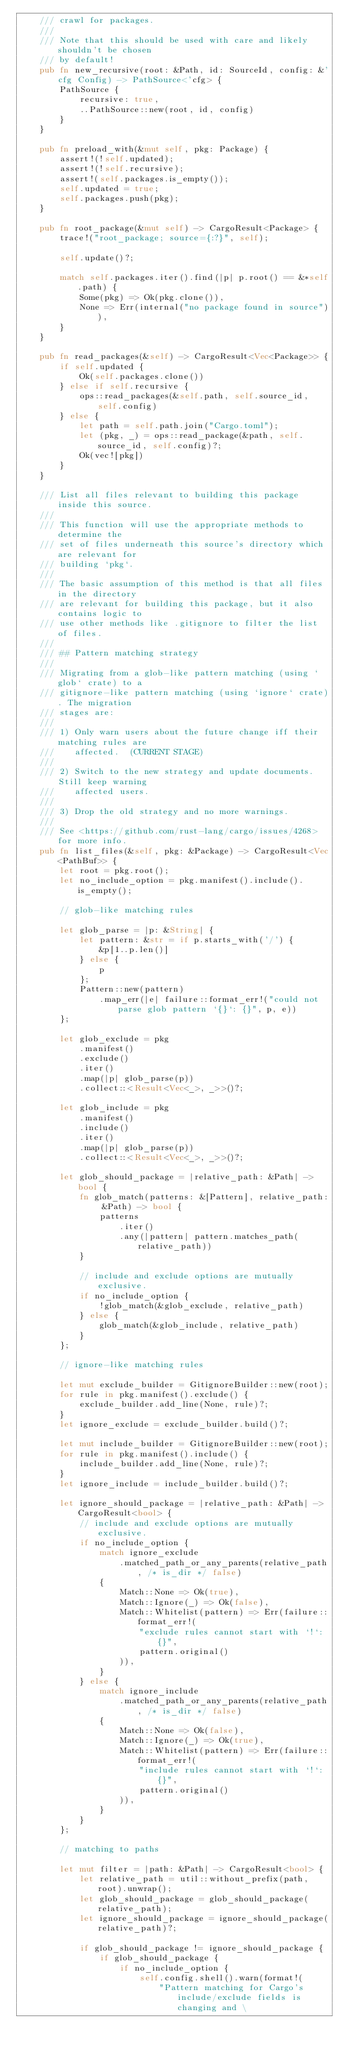Convert code to text. <code><loc_0><loc_0><loc_500><loc_500><_Rust_>    /// crawl for packages.
    ///
    /// Note that this should be used with care and likely shouldn't be chosen
    /// by default!
    pub fn new_recursive(root: &Path, id: SourceId, config: &'cfg Config) -> PathSource<'cfg> {
        PathSource {
            recursive: true,
            ..PathSource::new(root, id, config)
        }
    }

    pub fn preload_with(&mut self, pkg: Package) {
        assert!(!self.updated);
        assert!(!self.recursive);
        assert!(self.packages.is_empty());
        self.updated = true;
        self.packages.push(pkg);
    }

    pub fn root_package(&mut self) -> CargoResult<Package> {
        trace!("root_package; source={:?}", self);

        self.update()?;

        match self.packages.iter().find(|p| p.root() == &*self.path) {
            Some(pkg) => Ok(pkg.clone()),
            None => Err(internal("no package found in source")),
        }
    }

    pub fn read_packages(&self) -> CargoResult<Vec<Package>> {
        if self.updated {
            Ok(self.packages.clone())
        } else if self.recursive {
            ops::read_packages(&self.path, self.source_id, self.config)
        } else {
            let path = self.path.join("Cargo.toml");
            let (pkg, _) = ops::read_package(&path, self.source_id, self.config)?;
            Ok(vec![pkg])
        }
    }

    /// List all files relevant to building this package inside this source.
    ///
    /// This function will use the appropriate methods to determine the
    /// set of files underneath this source's directory which are relevant for
    /// building `pkg`.
    ///
    /// The basic assumption of this method is that all files in the directory
    /// are relevant for building this package, but it also contains logic to
    /// use other methods like .gitignore to filter the list of files.
    ///
    /// ## Pattern matching strategy
    ///
    /// Migrating from a glob-like pattern matching (using `glob` crate) to a
    /// gitignore-like pattern matching (using `ignore` crate). The migration
    /// stages are:
    ///
    /// 1) Only warn users about the future change iff their matching rules are
    ///    affected.  (CURRENT STAGE)
    ///
    /// 2) Switch to the new strategy and update documents. Still keep warning
    ///    affected users.
    ///
    /// 3) Drop the old strategy and no more warnings.
    ///
    /// See <https://github.com/rust-lang/cargo/issues/4268> for more info.
    pub fn list_files(&self, pkg: &Package) -> CargoResult<Vec<PathBuf>> {
        let root = pkg.root();
        let no_include_option = pkg.manifest().include().is_empty();

        // glob-like matching rules

        let glob_parse = |p: &String| {
            let pattern: &str = if p.starts_with('/') {
                &p[1..p.len()]
            } else {
                p
            };
            Pattern::new(pattern)
                .map_err(|e| failure::format_err!("could not parse glob pattern `{}`: {}", p, e))
        };

        let glob_exclude = pkg
            .manifest()
            .exclude()
            .iter()
            .map(|p| glob_parse(p))
            .collect::<Result<Vec<_>, _>>()?;

        let glob_include = pkg
            .manifest()
            .include()
            .iter()
            .map(|p| glob_parse(p))
            .collect::<Result<Vec<_>, _>>()?;

        let glob_should_package = |relative_path: &Path| -> bool {
            fn glob_match(patterns: &[Pattern], relative_path: &Path) -> bool {
                patterns
                    .iter()
                    .any(|pattern| pattern.matches_path(relative_path))
            }

            // include and exclude options are mutually exclusive.
            if no_include_option {
                !glob_match(&glob_exclude, relative_path)
            } else {
                glob_match(&glob_include, relative_path)
            }
        };

        // ignore-like matching rules

        let mut exclude_builder = GitignoreBuilder::new(root);
        for rule in pkg.manifest().exclude() {
            exclude_builder.add_line(None, rule)?;
        }
        let ignore_exclude = exclude_builder.build()?;

        let mut include_builder = GitignoreBuilder::new(root);
        for rule in pkg.manifest().include() {
            include_builder.add_line(None, rule)?;
        }
        let ignore_include = include_builder.build()?;

        let ignore_should_package = |relative_path: &Path| -> CargoResult<bool> {
            // include and exclude options are mutually exclusive.
            if no_include_option {
                match ignore_exclude
                    .matched_path_or_any_parents(relative_path, /* is_dir */ false)
                {
                    Match::None => Ok(true),
                    Match::Ignore(_) => Ok(false),
                    Match::Whitelist(pattern) => Err(failure::format_err!(
                        "exclude rules cannot start with `!`: {}",
                        pattern.original()
                    )),
                }
            } else {
                match ignore_include
                    .matched_path_or_any_parents(relative_path, /* is_dir */ false)
                {
                    Match::None => Ok(false),
                    Match::Ignore(_) => Ok(true),
                    Match::Whitelist(pattern) => Err(failure::format_err!(
                        "include rules cannot start with `!`: {}",
                        pattern.original()
                    )),
                }
            }
        };

        // matching to paths

        let mut filter = |path: &Path| -> CargoResult<bool> {
            let relative_path = util::without_prefix(path, root).unwrap();
            let glob_should_package = glob_should_package(relative_path);
            let ignore_should_package = ignore_should_package(relative_path)?;

            if glob_should_package != ignore_should_package {
                if glob_should_package {
                    if no_include_option {
                        self.config.shell().warn(format!(
                            "Pattern matching for Cargo's include/exclude fields is changing and \</code> 